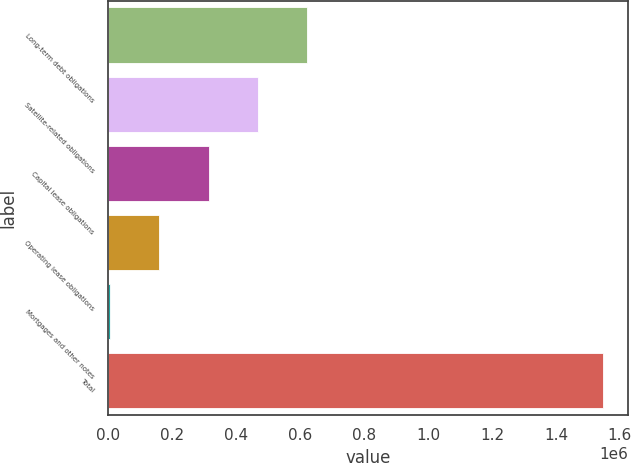<chart> <loc_0><loc_0><loc_500><loc_500><bar_chart><fcel>Long-term debt obligations<fcel>Satellite-related obligations<fcel>Capital lease obligations<fcel>Operating lease obligations<fcel>Mortgages and other notes<fcel>Total<nl><fcel>622131<fcel>467942<fcel>313753<fcel>159565<fcel>5376<fcel>1.54726e+06<nl></chart> 